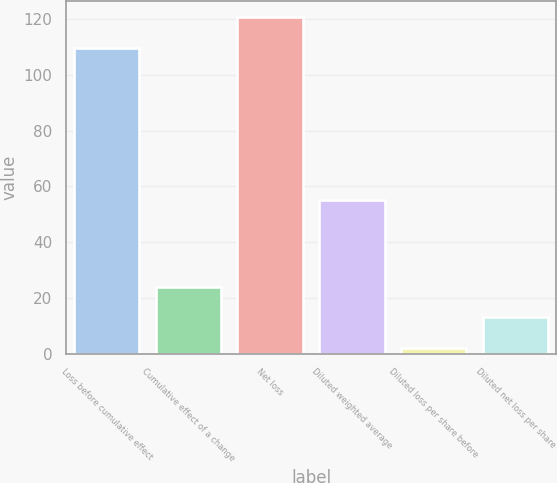Convert chart. <chart><loc_0><loc_0><loc_500><loc_500><bar_chart><fcel>Loss before cumulative effect<fcel>Cumulative effect of a change<fcel>Net loss<fcel>Diluted weighted average<fcel>Diluted loss per share before<fcel>Diluted net loss per share<nl><fcel>109.5<fcel>24.05<fcel>120.53<fcel>55<fcel>1.99<fcel>13.02<nl></chart> 